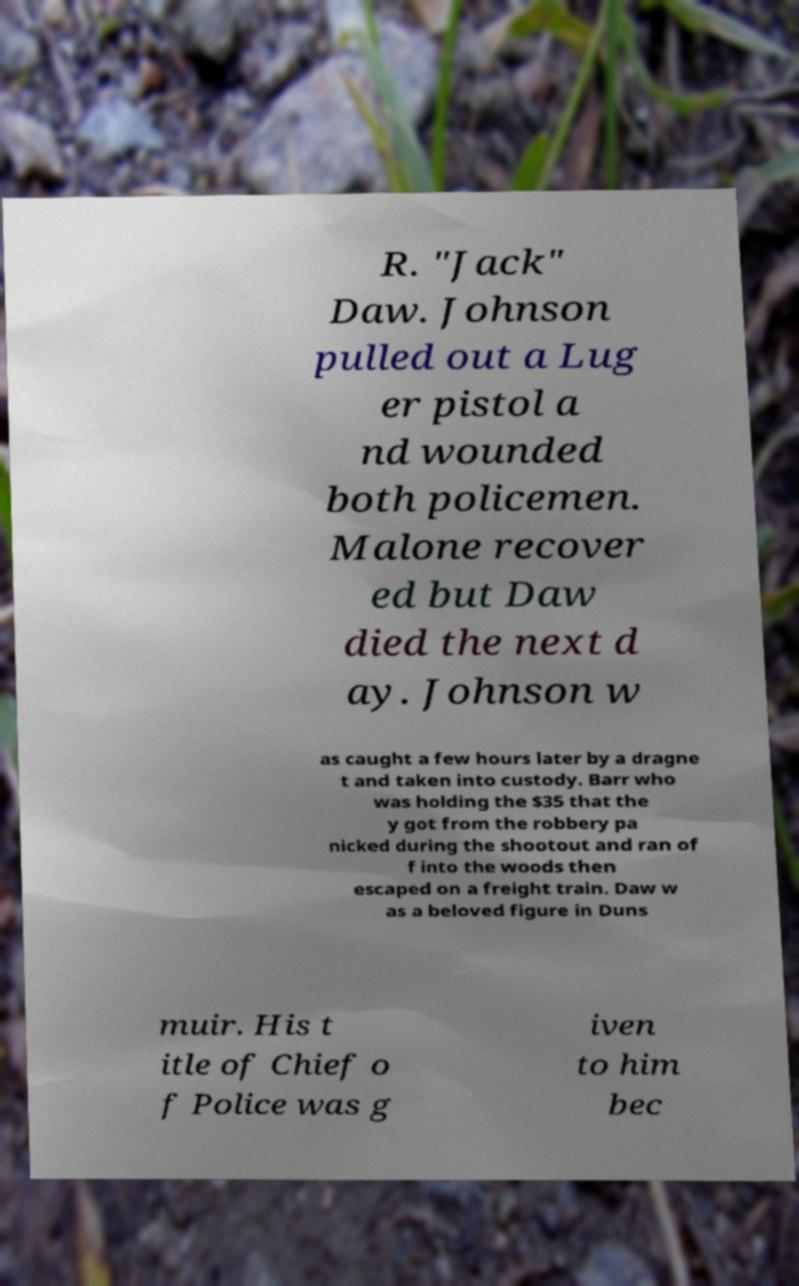Please identify and transcribe the text found in this image. R. "Jack" Daw. Johnson pulled out a Lug er pistol a nd wounded both policemen. Malone recover ed but Daw died the next d ay. Johnson w as caught a few hours later by a dragne t and taken into custody. Barr who was holding the $35 that the y got from the robbery pa nicked during the shootout and ran of f into the woods then escaped on a freight train. Daw w as a beloved figure in Duns muir. His t itle of Chief o f Police was g iven to him bec 